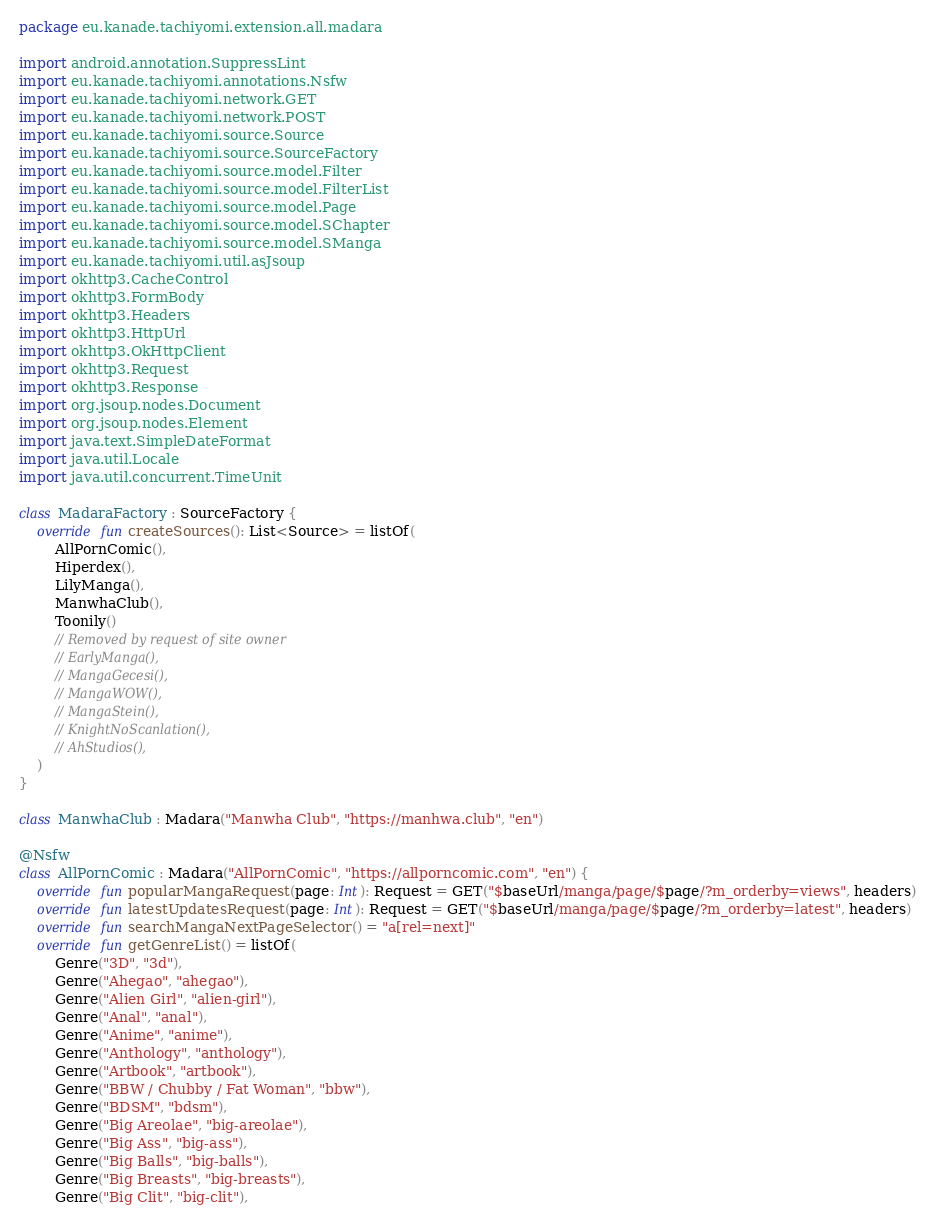<code> <loc_0><loc_0><loc_500><loc_500><_Kotlin_>package eu.kanade.tachiyomi.extension.all.madara

import android.annotation.SuppressLint
import eu.kanade.tachiyomi.annotations.Nsfw
import eu.kanade.tachiyomi.network.GET
import eu.kanade.tachiyomi.network.POST
import eu.kanade.tachiyomi.source.Source
import eu.kanade.tachiyomi.source.SourceFactory
import eu.kanade.tachiyomi.source.model.Filter
import eu.kanade.tachiyomi.source.model.FilterList
import eu.kanade.tachiyomi.source.model.Page
import eu.kanade.tachiyomi.source.model.SChapter
import eu.kanade.tachiyomi.source.model.SManga
import eu.kanade.tachiyomi.util.asJsoup
import okhttp3.CacheControl
import okhttp3.FormBody
import okhttp3.Headers
import okhttp3.HttpUrl
import okhttp3.OkHttpClient
import okhttp3.Request
import okhttp3.Response
import org.jsoup.nodes.Document
import org.jsoup.nodes.Element
import java.text.SimpleDateFormat
import java.util.Locale
import java.util.concurrent.TimeUnit

class MadaraFactory : SourceFactory {
    override fun createSources(): List<Source> = listOf(
        AllPornComic(),
        Hiperdex(),
        LilyManga(),
        ManwhaClub(),
        Toonily()
        // Removed by request of site owner
        // EarlyManga(),
        // MangaGecesi(),
        // MangaWOW(),
        // MangaStein(),
        // KnightNoScanlation(),
        // AhStudios(),
    )
}

class ManwhaClub : Madara("Manwha Club", "https://manhwa.club", "en")
                                   
@Nsfw
class AllPornComic : Madara("AllPornComic", "https://allporncomic.com", "en") {
    override fun popularMangaRequest(page: Int): Request = GET("$baseUrl/manga/page/$page/?m_orderby=views", headers)
    override fun latestUpdatesRequest(page: Int): Request = GET("$baseUrl/manga/page/$page/?m_orderby=latest", headers)
    override fun searchMangaNextPageSelector() = "a[rel=next]"
    override fun getGenreList() = listOf(
        Genre("3D", "3d"),
        Genre("Ahegao", "ahegao"),
        Genre("Alien Girl", "alien-girl"),
        Genre("Anal", "anal"),
        Genre("Anime", "anime"),
        Genre("Anthology", "anthology"),
        Genre("Artbook", "artbook"),
        Genre("BBW / Chubby / Fat Woman", "bbw"),
        Genre("BDSM", "bdsm"),
        Genre("Big Areolae", "big-areolae"),
        Genre("Big Ass", "big-ass"),
        Genre("Big Balls", "big-balls"),
        Genre("Big Breasts", "big-breasts"),
        Genre("Big Clit", "big-clit"),</code> 